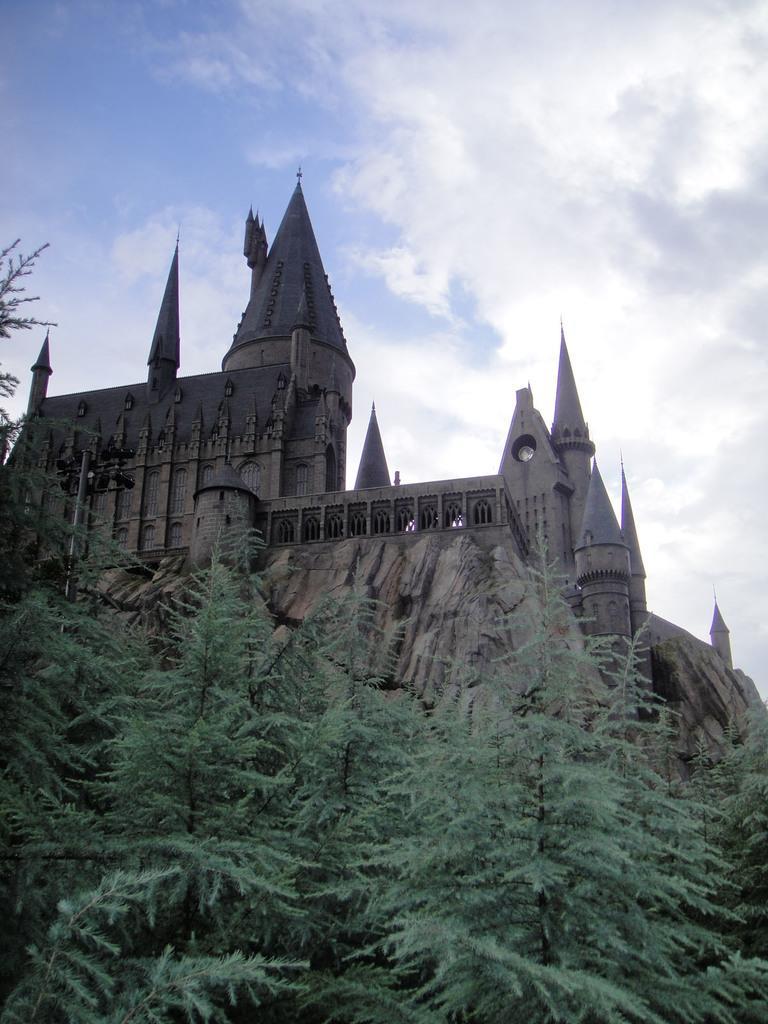In one or two sentences, can you explain what this image depicts? In this image I can see the building. To the side of the building I can see many trees. In the background there are clouds and the blue sky. 